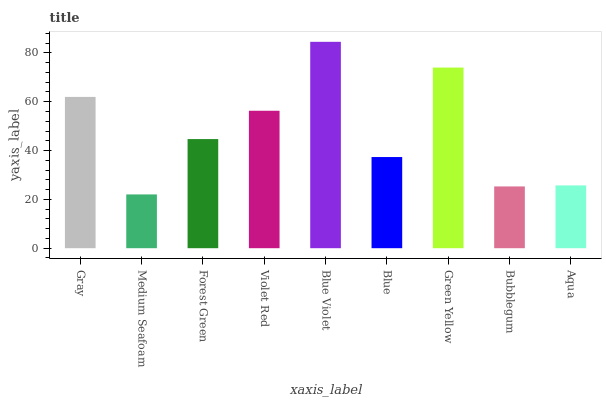Is Medium Seafoam the minimum?
Answer yes or no. Yes. Is Blue Violet the maximum?
Answer yes or no. Yes. Is Forest Green the minimum?
Answer yes or no. No. Is Forest Green the maximum?
Answer yes or no. No. Is Forest Green greater than Medium Seafoam?
Answer yes or no. Yes. Is Medium Seafoam less than Forest Green?
Answer yes or no. Yes. Is Medium Seafoam greater than Forest Green?
Answer yes or no. No. Is Forest Green less than Medium Seafoam?
Answer yes or no. No. Is Forest Green the high median?
Answer yes or no. Yes. Is Forest Green the low median?
Answer yes or no. Yes. Is Blue Violet the high median?
Answer yes or no. No. Is Green Yellow the low median?
Answer yes or no. No. 